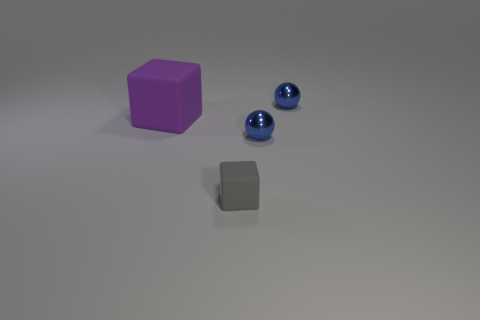Add 1 big red shiny objects. How many objects exist? 5 Add 2 spheres. How many spheres are left? 4 Add 4 big purple things. How many big purple things exist? 5 Subtract 1 blue spheres. How many objects are left? 3 Subtract all big things. Subtract all gray matte things. How many objects are left? 2 